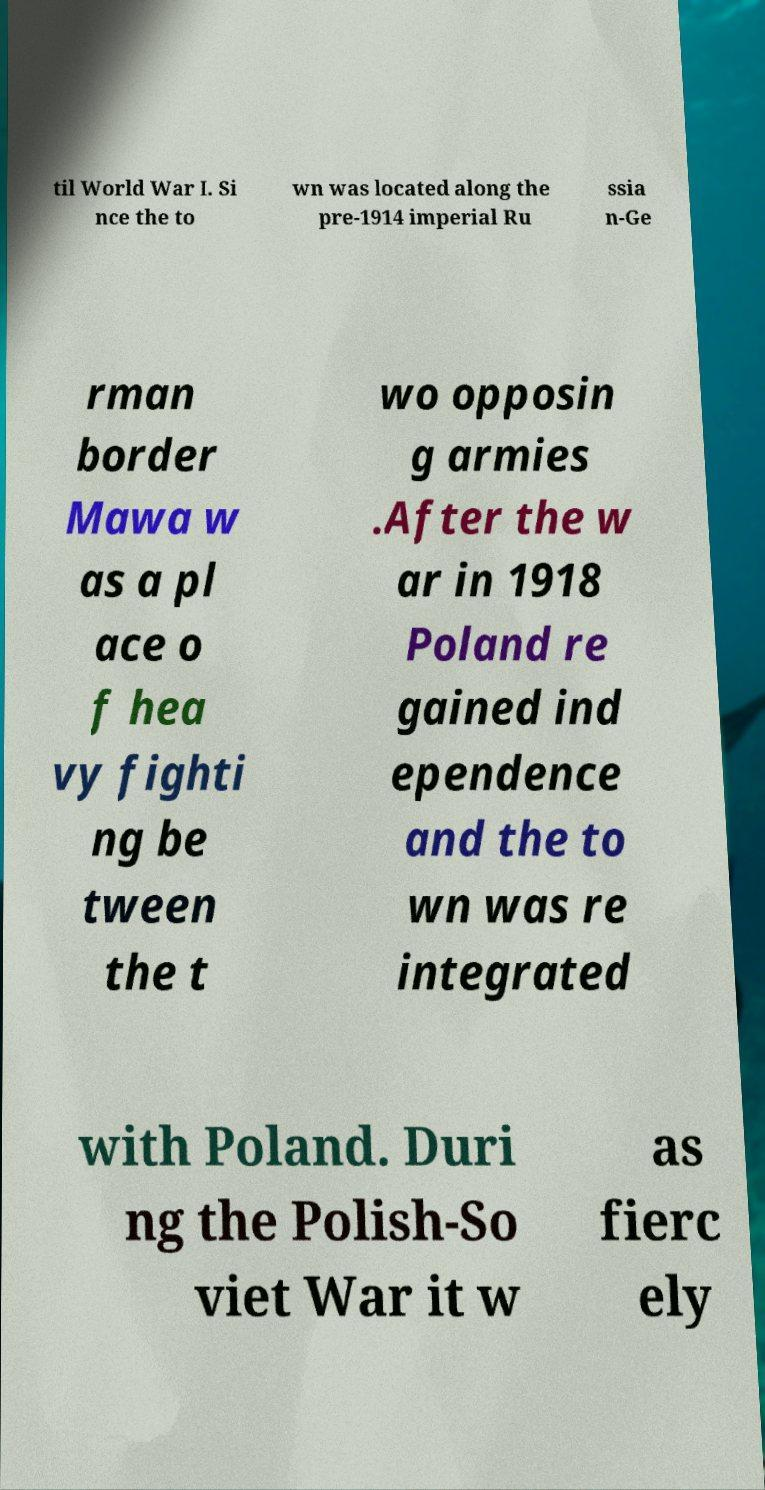What messages or text are displayed in this image? I need them in a readable, typed format. til World War I. Si nce the to wn was located along the pre-1914 imperial Ru ssia n-Ge rman border Mawa w as a pl ace o f hea vy fighti ng be tween the t wo opposin g armies .After the w ar in 1918 Poland re gained ind ependence and the to wn was re integrated with Poland. Duri ng the Polish-So viet War it w as fierc ely 